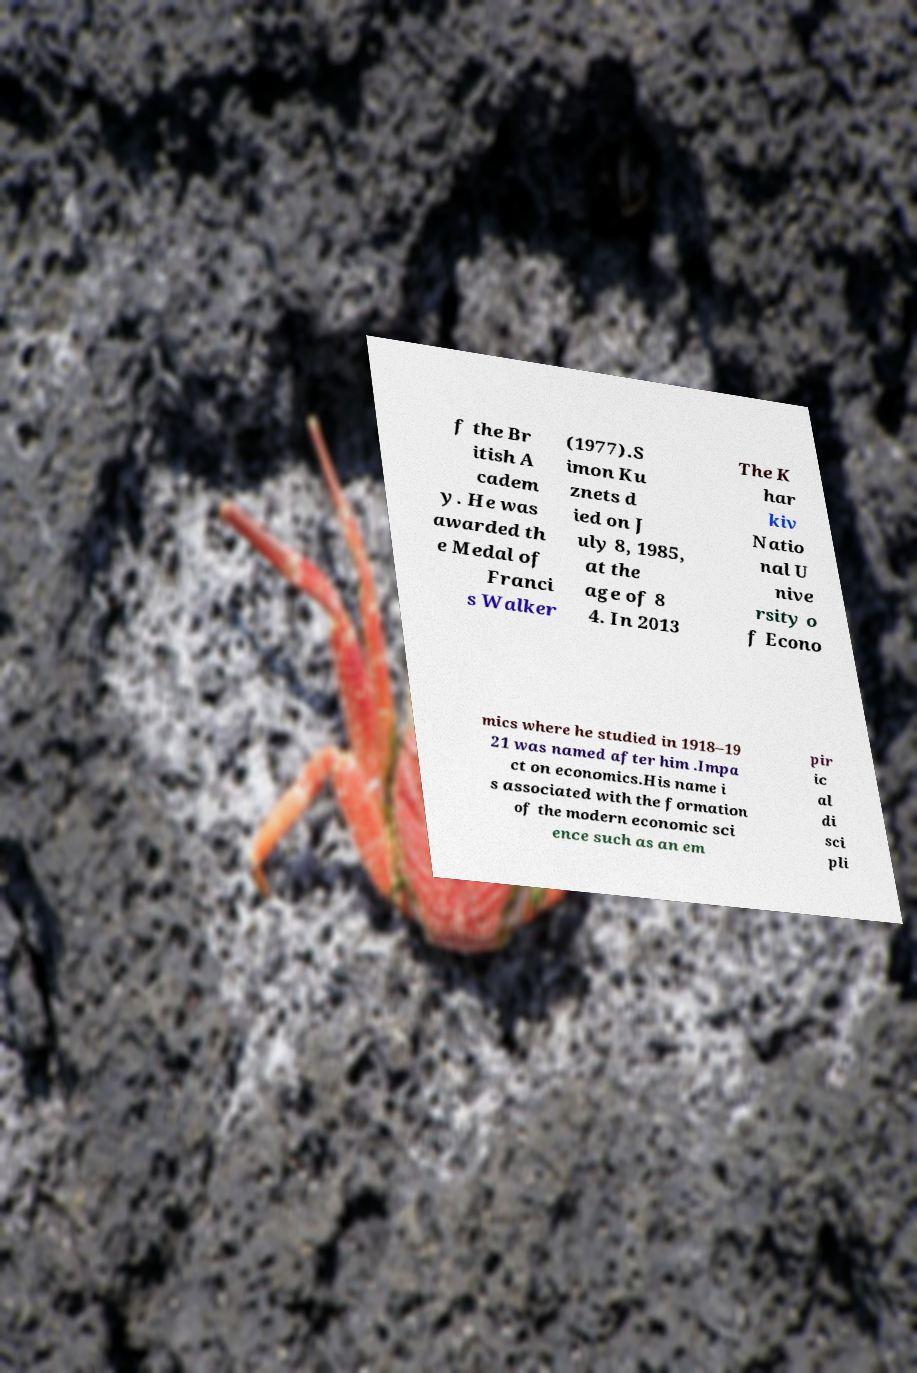Could you extract and type out the text from this image? f the Br itish A cadem y. He was awarded th e Medal of Franci s Walker (1977).S imon Ku znets d ied on J uly 8, 1985, at the age of 8 4. In 2013 The K har kiv Natio nal U nive rsity o f Econo mics where he studied in 1918–19 21 was named after him .Impa ct on economics.His name i s associated with the formation of the modern economic sci ence such as an em pir ic al di sci pli 